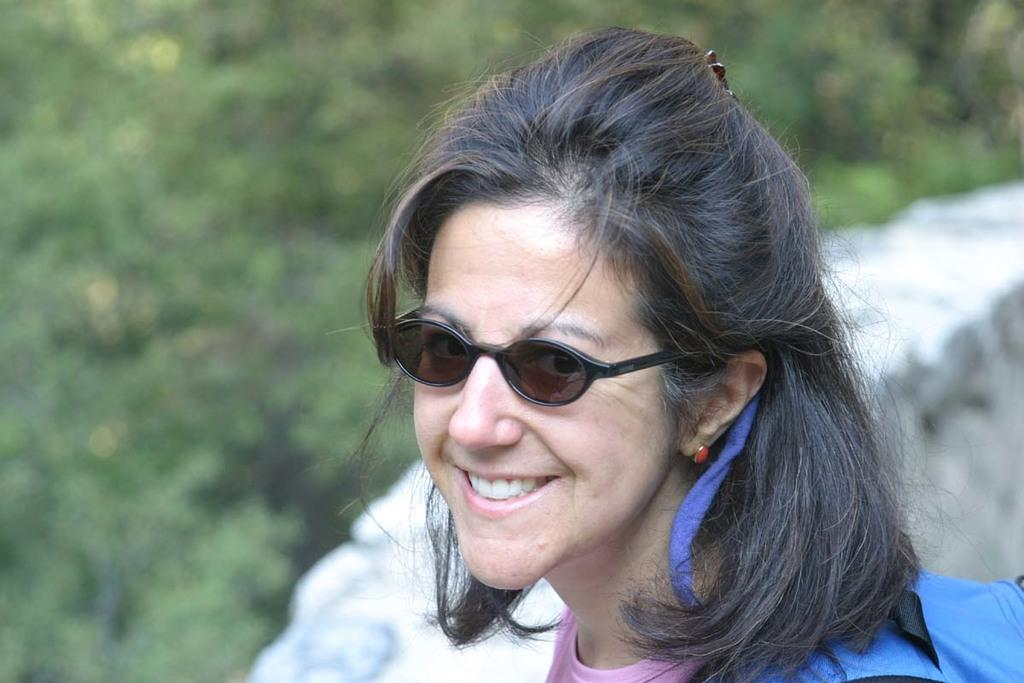Who is the main subject in the image? There is a lady in the image. What is the lady doing in the image? The lady is smiling. What is the lady wearing on her shoulder? The lady is wearing a bag on her shoulder. What can be seen in the background of the image? There are trees in the background of the image. What type of degree does the lady hold in the image? There is no information about the lady's degree in the image. 